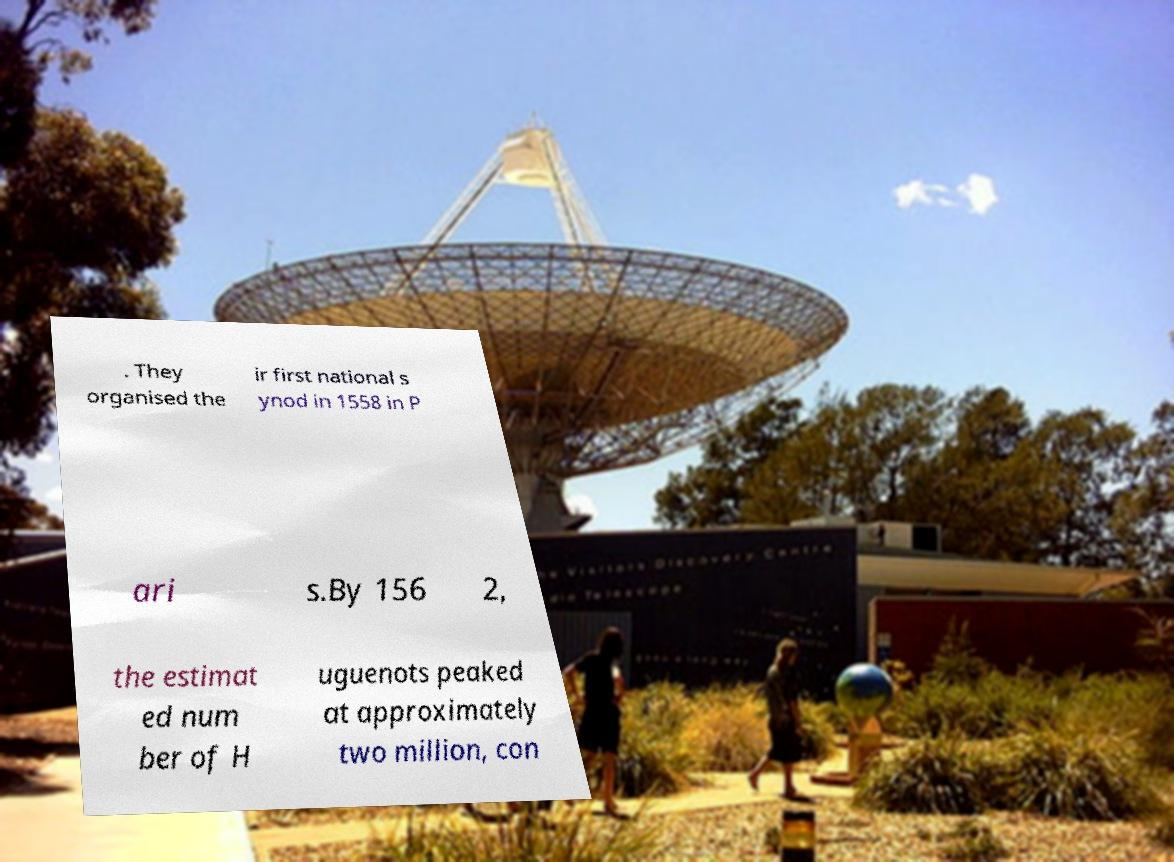What messages or text are displayed in this image? I need them in a readable, typed format. . They organised the ir first national s ynod in 1558 in P ari s.By 156 2, the estimat ed num ber of H uguenots peaked at approximately two million, con 